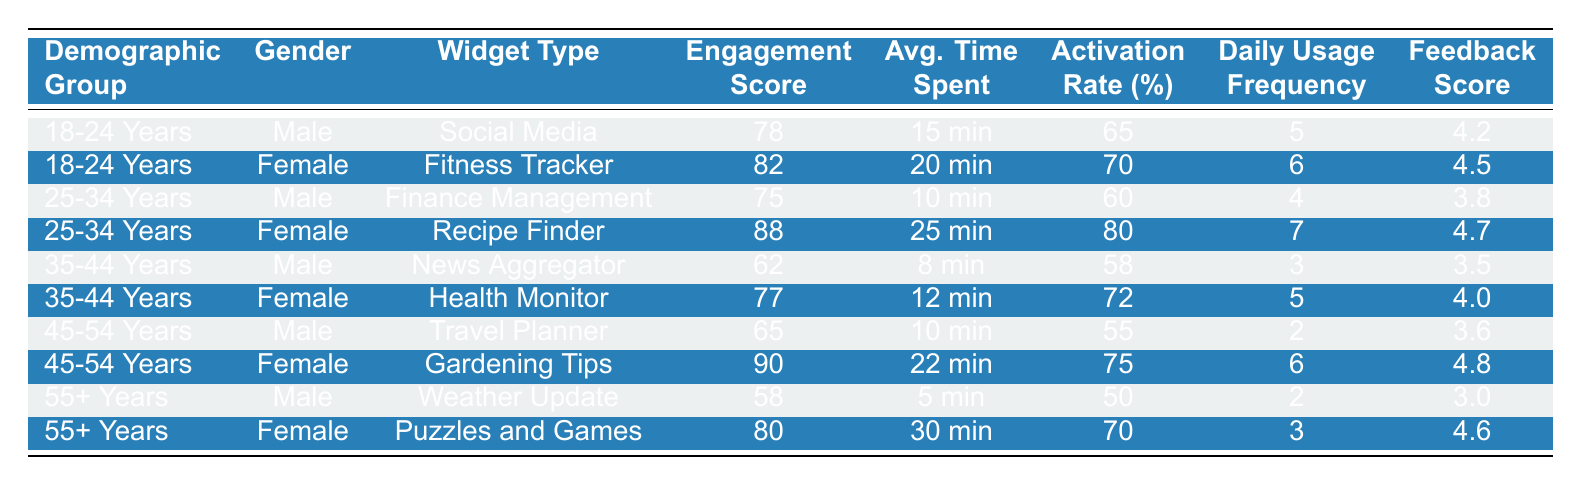What is the engagement score for the "Fitness Tracker" widget? Looking at the table, the "Fitness Tracker" widget is under the demographic group "18-24 Years" for Female, and it has an engagement score listed as 82.
Answer: 82 Which widget type has the highest average time spent? The table shows that the "Puzzles and Games" widget (for the 55+ Years Female demographic) has an average time spent of 30 minutes, which is higher than all other widgets listed.
Answer: 30 minutes Is the feedback score for "Gardening Tips" better than that for "Finance Management"? The feedback score for "Gardening Tips" is 4.8, while for "Finance Management," it is 3.8. Since 4.8 is greater than 3.8, the statement is true.
Answer: Yes What is the average engagement score for males aged 35-44 years? Looking at the table, the engagement scores for males aged 35-44 are: 62. To find the average for just this demographic group, we need only refer to this single score, which means the average is 62.
Answer: 62 Which demographic group has the highest activation rate for their widget? The highest activation rate is found for the "Recipe Finder" widget in the 25-34 Years Female demographic, at 80%. This is higher than all the activation rates listed for all other demographic groups.
Answer: 80% How much more time do females aged 45-54 spend on average with widgets compared to males in the same age group? For females aged 45-54 ("Gardening Tips"), the average time spent is 22 minutes, whereas for males aged 45-54 ("Travel Planner"), it is 10 minutes. The difference is calculated as 22 - 10 = 12 minutes.
Answer: 12 minutes Which widget type is preferred by the youngest male demographic group based on engagement score? The highest engagement score for the male demographic group "18-24 Years" is for the "Social Media" widget, with a score of 78. There is no higher score for this age group listed in the table.
Answer: Social Media What is the difference in daily usage frequency between the "Weather Update" and "Puzzles and Games" widgets? The "Weather Update" widget (male, 55+ Years) has a daily usage frequency of 2, while "Puzzles and Games" (female, 55+ Years) has a frequency of 3. The difference is calculated as 3 - 2 = 1.
Answer: 1 Which widget type received the most positive feedback score? Examining the feedback scores, the "Gardening Tips" widget has the highest feedback score at 4.8. No other widget scores higher than this.
Answer: Gardening Tips What is the average engagement score across all widget types? The engagement scores listed in the table are: 78, 82, 75, 88, 62, 77, 65, 90, 58, and 80, with a total of 10 scores. To calculate the average: (78 + 82 + 75 + 88 + 62 + 77 + 65 + 90 + 58 + 80) =  785, then 785 / 10 = 78.5.
Answer: 78.5 